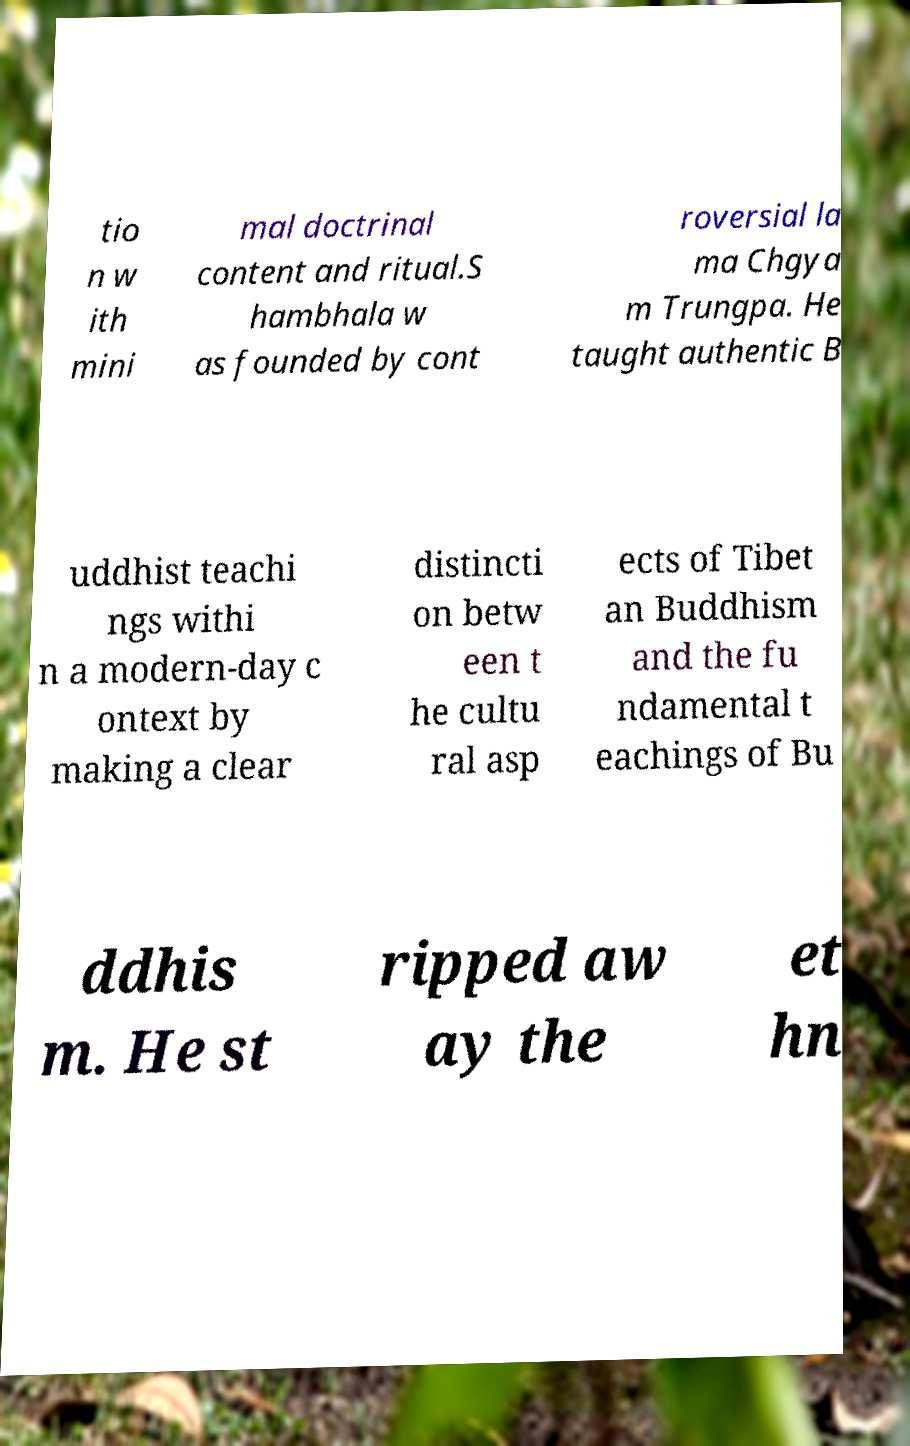I need the written content from this picture converted into text. Can you do that? tio n w ith mini mal doctrinal content and ritual.S hambhala w as founded by cont roversial la ma Chgya m Trungpa. He taught authentic B uddhist teachi ngs withi n a modern-day c ontext by making a clear distincti on betw een t he cultu ral asp ects of Tibet an Buddhism and the fu ndamental t eachings of Bu ddhis m. He st ripped aw ay the et hn 